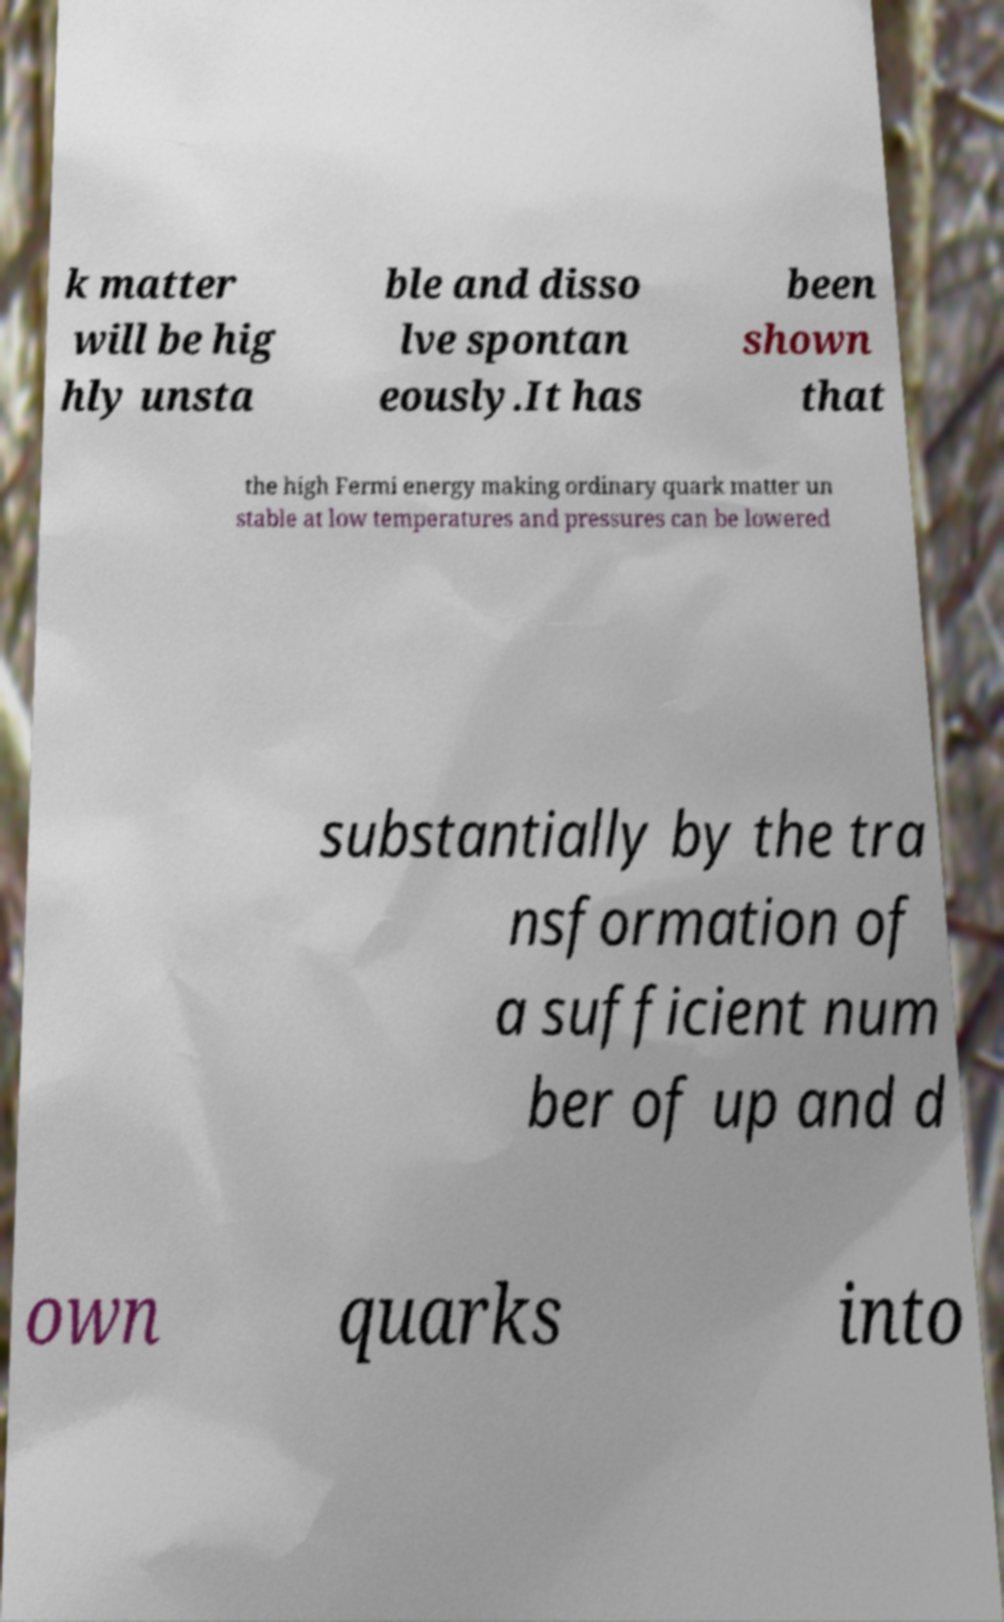Could you extract and type out the text from this image? k matter will be hig hly unsta ble and disso lve spontan eously.It has been shown that the high Fermi energy making ordinary quark matter un stable at low temperatures and pressures can be lowered substantially by the tra nsformation of a sufficient num ber of up and d own quarks into 